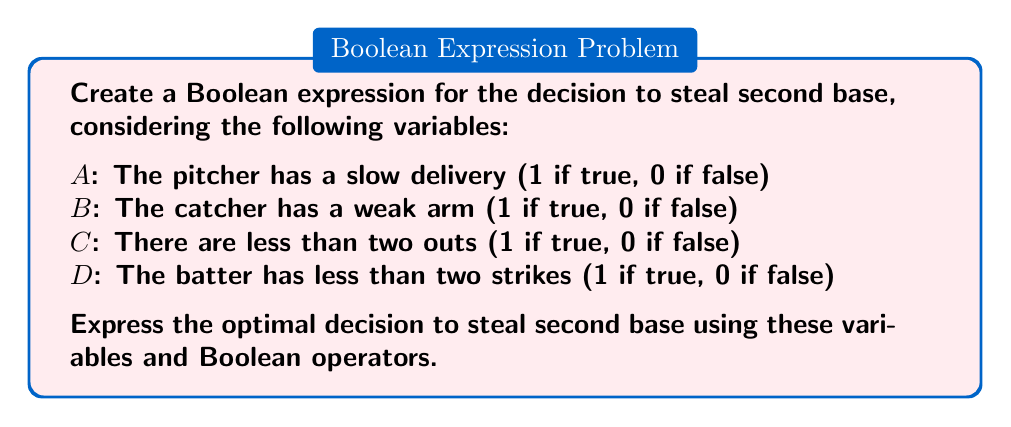Could you help me with this problem? To create a Boolean expression for the optimal decision to steal second base, we need to consider the given variables and how they affect the decision-making process. Let's break it down step-by-step:

1. A pitcher with a slow delivery (A) increases the chances of a successful steal.
2. A catcher with a weak arm (B) also improves the odds of stealing successfully.
3. Having less than two outs (C) makes stealing more favorable, as it reduces the risk of ending the inning if caught.
4. Having less than two strikes on the batter (D) is preferable, as it allows for the possibility of a hit-and-run play.

The optimal decision to steal second base would ideally consider all these factors. We can express this as a Boolean function:

$$ f(A, B, C, D) = A \cdot B \cdot C \cdot D $$

This expression means that the ideal situation to steal second base is when all conditions are true (1). However, in real baseball scenarios, we might not always have all conditions met. A more realistic expression would consider stealing when most conditions are favorable:

$$ f(A, B, C, D) = (A + B) \cdot C \cdot D $$

This expression suggests that we should attempt to steal when:
- Either the pitcher has a slow delivery OR the catcher has a weak arm (A + B)
- AND there are less than two outs (C)
- AND the batter has less than two strikes (D)

This Boolean expression balances the most critical factors for a successful steal while allowing for some flexibility in the decision-making process.
Answer: $$ (A + B) \cdot C \cdot D $$ 